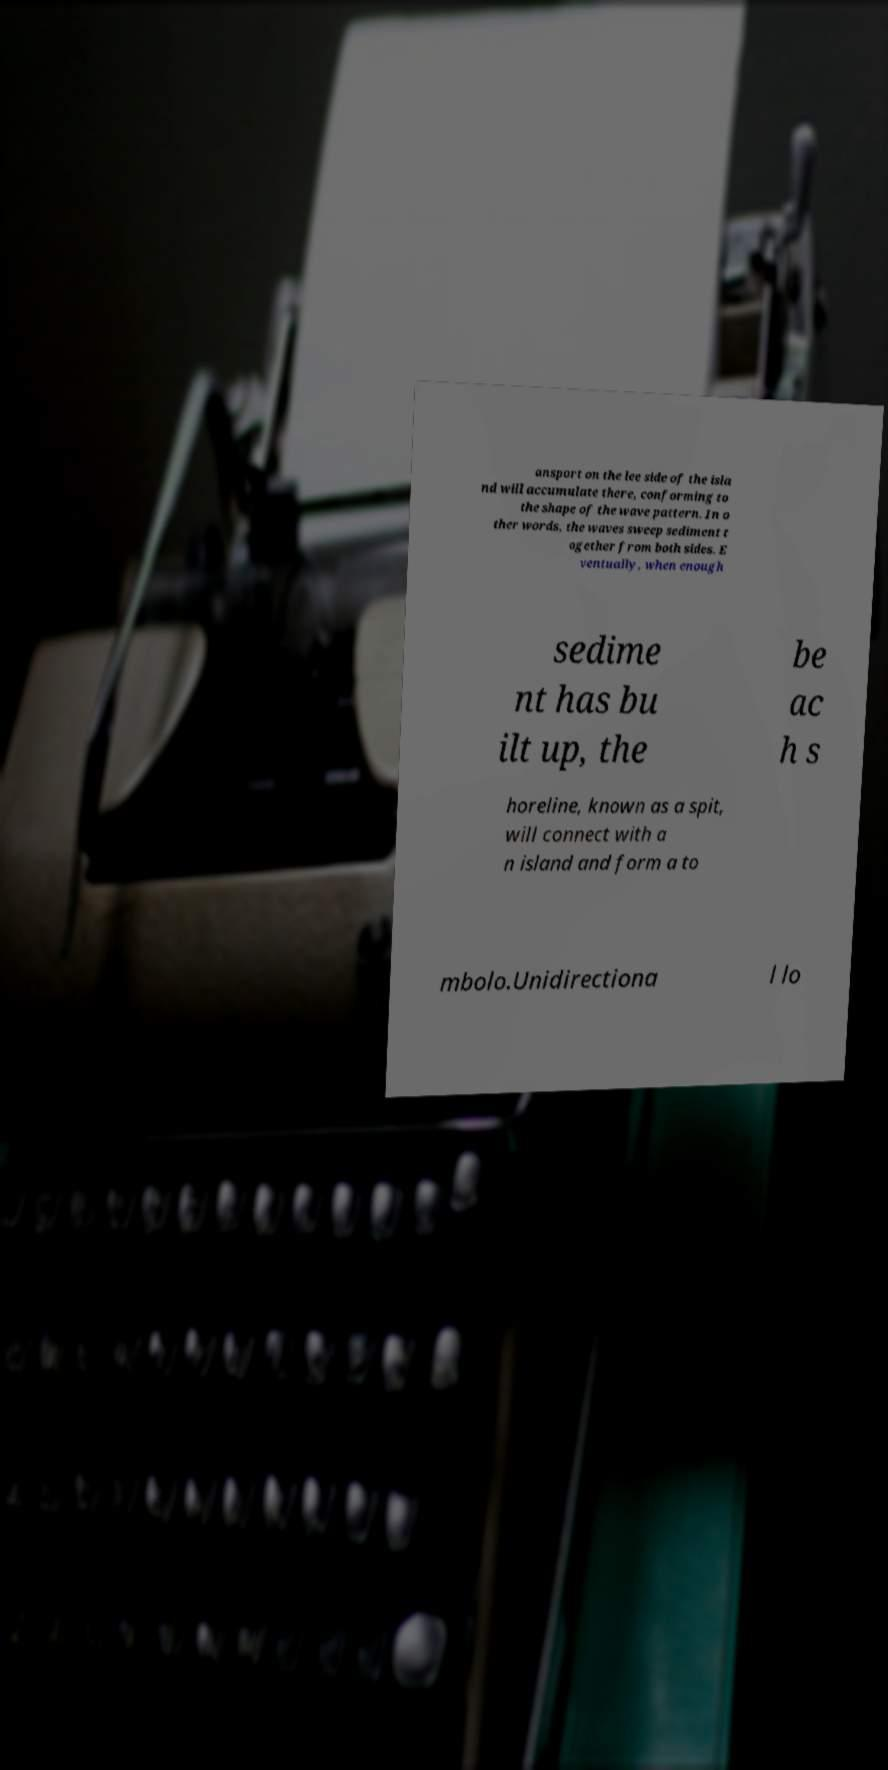What messages or text are displayed in this image? I need them in a readable, typed format. ansport on the lee side of the isla nd will accumulate there, conforming to the shape of the wave pattern. In o ther words, the waves sweep sediment t ogether from both sides. E ventually, when enough sedime nt has bu ilt up, the be ac h s horeline, known as a spit, will connect with a n island and form a to mbolo.Unidirectiona l lo 